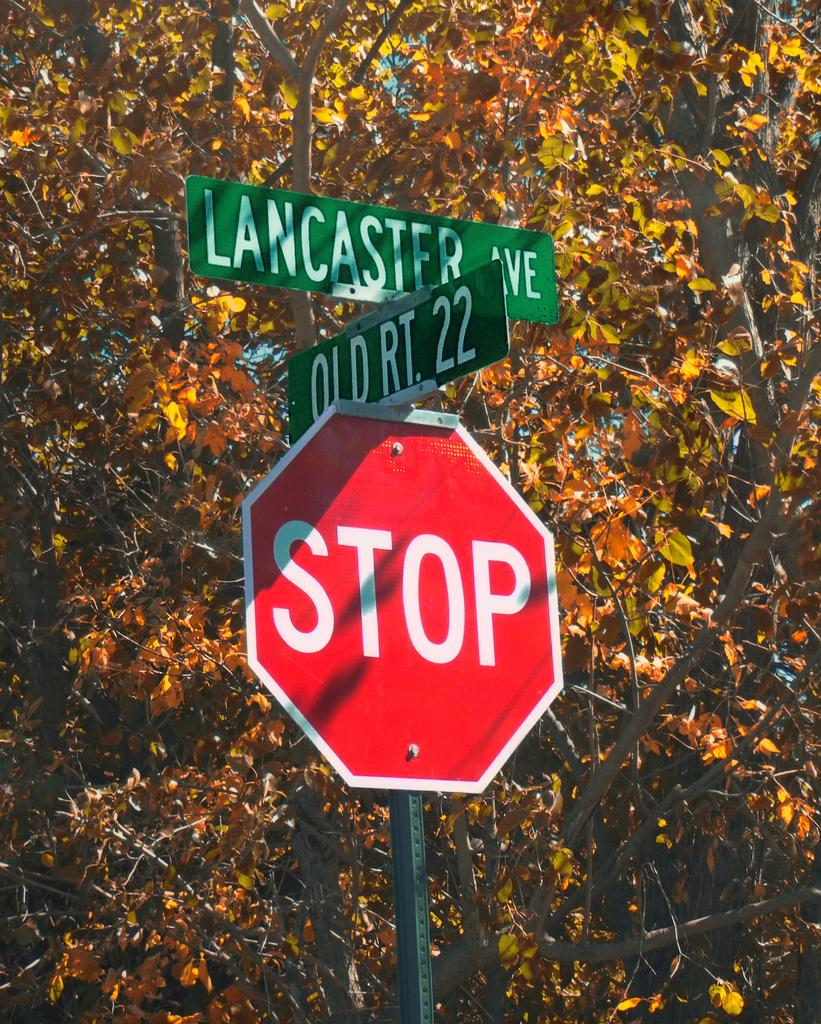Provide a one-sentence caption for the provided image. A STOP sign below street signs for Lancaster ave and Old Rt. 22. 